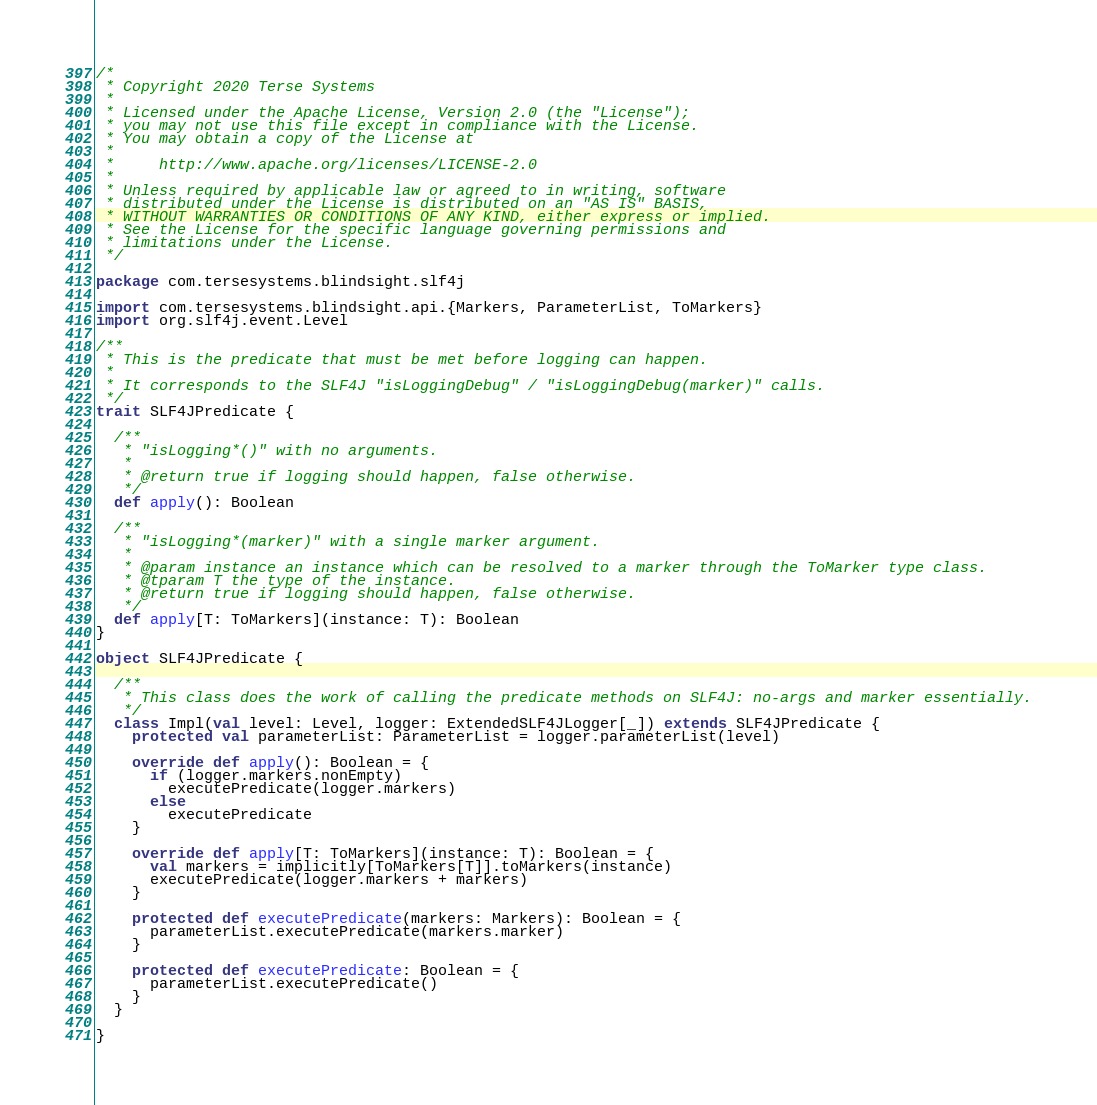Convert code to text. <code><loc_0><loc_0><loc_500><loc_500><_Scala_>/*
 * Copyright 2020 Terse Systems
 *
 * Licensed under the Apache License, Version 2.0 (the "License");
 * you may not use this file except in compliance with the License.
 * You may obtain a copy of the License at
 *
 *     http://www.apache.org/licenses/LICENSE-2.0
 *
 * Unless required by applicable law or agreed to in writing, software
 * distributed under the License is distributed on an "AS IS" BASIS,
 * WITHOUT WARRANTIES OR CONDITIONS OF ANY KIND, either express or implied.
 * See the License for the specific language governing permissions and
 * limitations under the License.
 */

package com.tersesystems.blindsight.slf4j

import com.tersesystems.blindsight.api.{Markers, ParameterList, ToMarkers}
import org.slf4j.event.Level

/**
 * This is the predicate that must be met before logging can happen.
 *
 * It corresponds to the SLF4J "isLoggingDebug" / "isLoggingDebug(marker)" calls.
 */
trait SLF4JPredicate {

  /**
   * "isLogging*()" with no arguments.
   *
   * @return true if logging should happen, false otherwise.
   */
  def apply(): Boolean

  /**
   * "isLogging*(marker)" with a single marker argument.
   *
   * @param instance an instance which can be resolved to a marker through the ToMarker type class.
   * @tparam T the type of the instance.
   * @return true if logging should happen, false otherwise.
   */
  def apply[T: ToMarkers](instance: T): Boolean
}

object SLF4JPredicate {

  /**
   * This class does the work of calling the predicate methods on SLF4J: no-args and marker essentially.
   */
  class Impl(val level: Level, logger: ExtendedSLF4JLogger[_]) extends SLF4JPredicate {
    protected val parameterList: ParameterList = logger.parameterList(level)

    override def apply(): Boolean = {
      if (logger.markers.nonEmpty)
        executePredicate(logger.markers)
      else
        executePredicate
    }

    override def apply[T: ToMarkers](instance: T): Boolean = {
      val markers = implicitly[ToMarkers[T]].toMarkers(instance)
      executePredicate(logger.markers + markers)
    }

    protected def executePredicate(markers: Markers): Boolean = {
      parameterList.executePredicate(markers.marker)
    }

    protected def executePredicate: Boolean = {
      parameterList.executePredicate()
    }
  }

}
</code> 